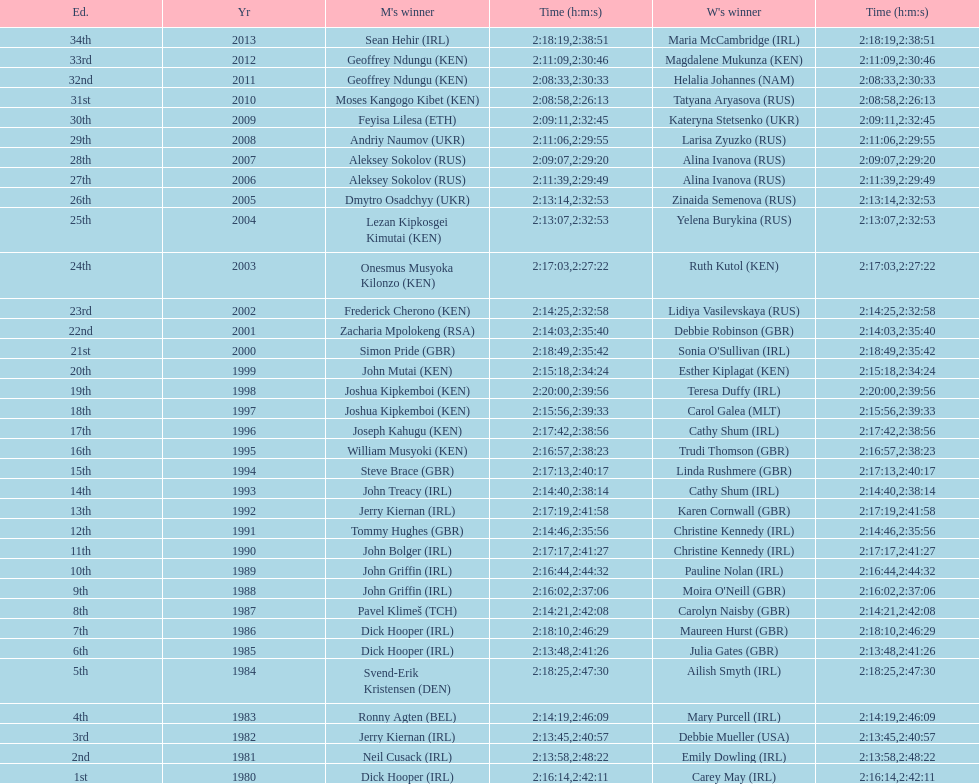Could you parse the entire table? {'header': ['Ed.', 'Yr', "M's winner", 'Time (h:m:s)', "W's winner", 'Time (h:m:s)'], 'rows': [['34th', '2013', 'Sean Hehir\xa0(IRL)', '2:18:19', 'Maria McCambridge\xa0(IRL)', '2:38:51'], ['33rd', '2012', 'Geoffrey Ndungu\xa0(KEN)', '2:11:09', 'Magdalene Mukunza\xa0(KEN)', '2:30:46'], ['32nd', '2011', 'Geoffrey Ndungu\xa0(KEN)', '2:08:33', 'Helalia Johannes\xa0(NAM)', '2:30:33'], ['31st', '2010', 'Moses Kangogo Kibet\xa0(KEN)', '2:08:58', 'Tatyana Aryasova\xa0(RUS)', '2:26:13'], ['30th', '2009', 'Feyisa Lilesa\xa0(ETH)', '2:09:11', 'Kateryna Stetsenko\xa0(UKR)', '2:32:45'], ['29th', '2008', 'Andriy Naumov\xa0(UKR)', '2:11:06', 'Larisa Zyuzko\xa0(RUS)', '2:29:55'], ['28th', '2007', 'Aleksey Sokolov\xa0(RUS)', '2:09:07', 'Alina Ivanova\xa0(RUS)', '2:29:20'], ['27th', '2006', 'Aleksey Sokolov\xa0(RUS)', '2:11:39', 'Alina Ivanova\xa0(RUS)', '2:29:49'], ['26th', '2005', 'Dmytro Osadchyy\xa0(UKR)', '2:13:14', 'Zinaida Semenova\xa0(RUS)', '2:32:53'], ['25th', '2004', 'Lezan Kipkosgei Kimutai\xa0(KEN)', '2:13:07', 'Yelena Burykina\xa0(RUS)', '2:32:53'], ['24th', '2003', 'Onesmus Musyoka Kilonzo\xa0(KEN)', '2:17:03', 'Ruth Kutol\xa0(KEN)', '2:27:22'], ['23rd', '2002', 'Frederick Cherono\xa0(KEN)', '2:14:25', 'Lidiya Vasilevskaya\xa0(RUS)', '2:32:58'], ['22nd', '2001', 'Zacharia Mpolokeng\xa0(RSA)', '2:14:03', 'Debbie Robinson\xa0(GBR)', '2:35:40'], ['21st', '2000', 'Simon Pride\xa0(GBR)', '2:18:49', "Sonia O'Sullivan\xa0(IRL)", '2:35:42'], ['20th', '1999', 'John Mutai\xa0(KEN)', '2:15:18', 'Esther Kiplagat\xa0(KEN)', '2:34:24'], ['19th', '1998', 'Joshua Kipkemboi\xa0(KEN)', '2:20:00', 'Teresa Duffy\xa0(IRL)', '2:39:56'], ['18th', '1997', 'Joshua Kipkemboi\xa0(KEN)', '2:15:56', 'Carol Galea\xa0(MLT)', '2:39:33'], ['17th', '1996', 'Joseph Kahugu\xa0(KEN)', '2:17:42', 'Cathy Shum\xa0(IRL)', '2:38:56'], ['16th', '1995', 'William Musyoki\xa0(KEN)', '2:16:57', 'Trudi Thomson\xa0(GBR)', '2:38:23'], ['15th', '1994', 'Steve Brace\xa0(GBR)', '2:17:13', 'Linda Rushmere\xa0(GBR)', '2:40:17'], ['14th', '1993', 'John Treacy\xa0(IRL)', '2:14:40', 'Cathy Shum\xa0(IRL)', '2:38:14'], ['13th', '1992', 'Jerry Kiernan\xa0(IRL)', '2:17:19', 'Karen Cornwall\xa0(GBR)', '2:41:58'], ['12th', '1991', 'Tommy Hughes\xa0(GBR)', '2:14:46', 'Christine Kennedy\xa0(IRL)', '2:35:56'], ['11th', '1990', 'John Bolger\xa0(IRL)', '2:17:17', 'Christine Kennedy\xa0(IRL)', '2:41:27'], ['10th', '1989', 'John Griffin\xa0(IRL)', '2:16:44', 'Pauline Nolan\xa0(IRL)', '2:44:32'], ['9th', '1988', 'John Griffin\xa0(IRL)', '2:16:02', "Moira O'Neill\xa0(GBR)", '2:37:06'], ['8th', '1987', 'Pavel Klimeš\xa0(TCH)', '2:14:21', 'Carolyn Naisby\xa0(GBR)', '2:42:08'], ['7th', '1986', 'Dick Hooper\xa0(IRL)', '2:18:10', 'Maureen Hurst\xa0(GBR)', '2:46:29'], ['6th', '1985', 'Dick Hooper\xa0(IRL)', '2:13:48', 'Julia Gates\xa0(GBR)', '2:41:26'], ['5th', '1984', 'Svend-Erik Kristensen\xa0(DEN)', '2:18:25', 'Ailish Smyth\xa0(IRL)', '2:47:30'], ['4th', '1983', 'Ronny Agten\xa0(BEL)', '2:14:19', 'Mary Purcell\xa0(IRL)', '2:46:09'], ['3rd', '1982', 'Jerry Kiernan\xa0(IRL)', '2:13:45', 'Debbie Mueller\xa0(USA)', '2:40:57'], ['2nd', '1981', 'Neil Cusack\xa0(IRL)', '2:13:58', 'Emily Dowling\xa0(IRL)', '2:48:22'], ['1st', '1980', 'Dick Hooper\xa0(IRL)', '2:16:14', 'Carey May\xa0(IRL)', '2:42:11']]} Who had the most amount of time out of all the runners? Maria McCambridge (IRL). 